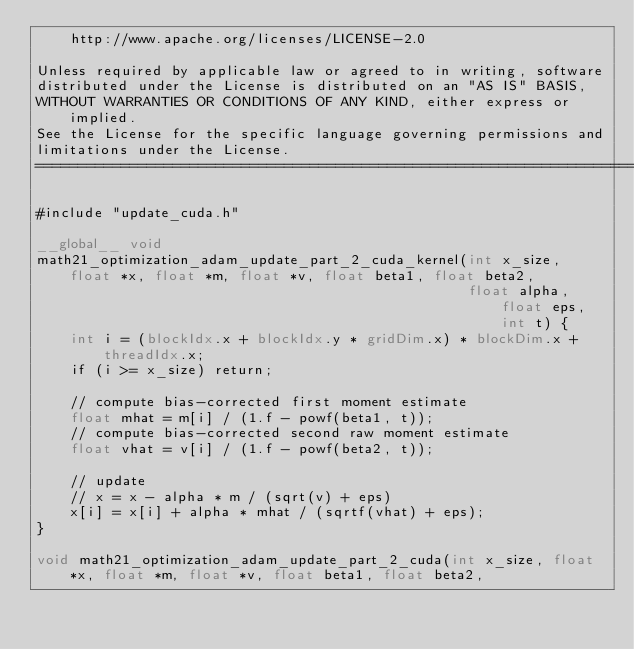<code> <loc_0><loc_0><loc_500><loc_500><_Cuda_>    http://www.apache.org/licenses/LICENSE-2.0

Unless required by applicable law or agreed to in writing, software
distributed under the License is distributed on an "AS IS" BASIS,
WITHOUT WARRANTIES OR CONDITIONS OF ANY KIND, either express or implied.
See the License for the specific language governing permissions and
limitations under the License.
==============================================================================*/

#include "update_cuda.h"

__global__ void
math21_optimization_adam_update_part_2_cuda_kernel(int x_size, float *x, float *m, float *v, float beta1, float beta2,
                                                   float alpha, float eps, int t) {
    int i = (blockIdx.x + blockIdx.y * gridDim.x) * blockDim.x + threadIdx.x;
    if (i >= x_size) return;

    // compute bias-corrected first moment estimate
    float mhat = m[i] / (1.f - powf(beta1, t));
    // compute bias-corrected second raw moment estimate
    float vhat = v[i] / (1.f - powf(beta2, t));

    // update
    // x = x - alpha * m / (sqrt(v) + eps)
    x[i] = x[i] + alpha * mhat / (sqrtf(vhat) + eps);
}

void math21_optimization_adam_update_part_2_cuda(int x_size, float *x, float *m, float *v, float beta1, float beta2,</code> 